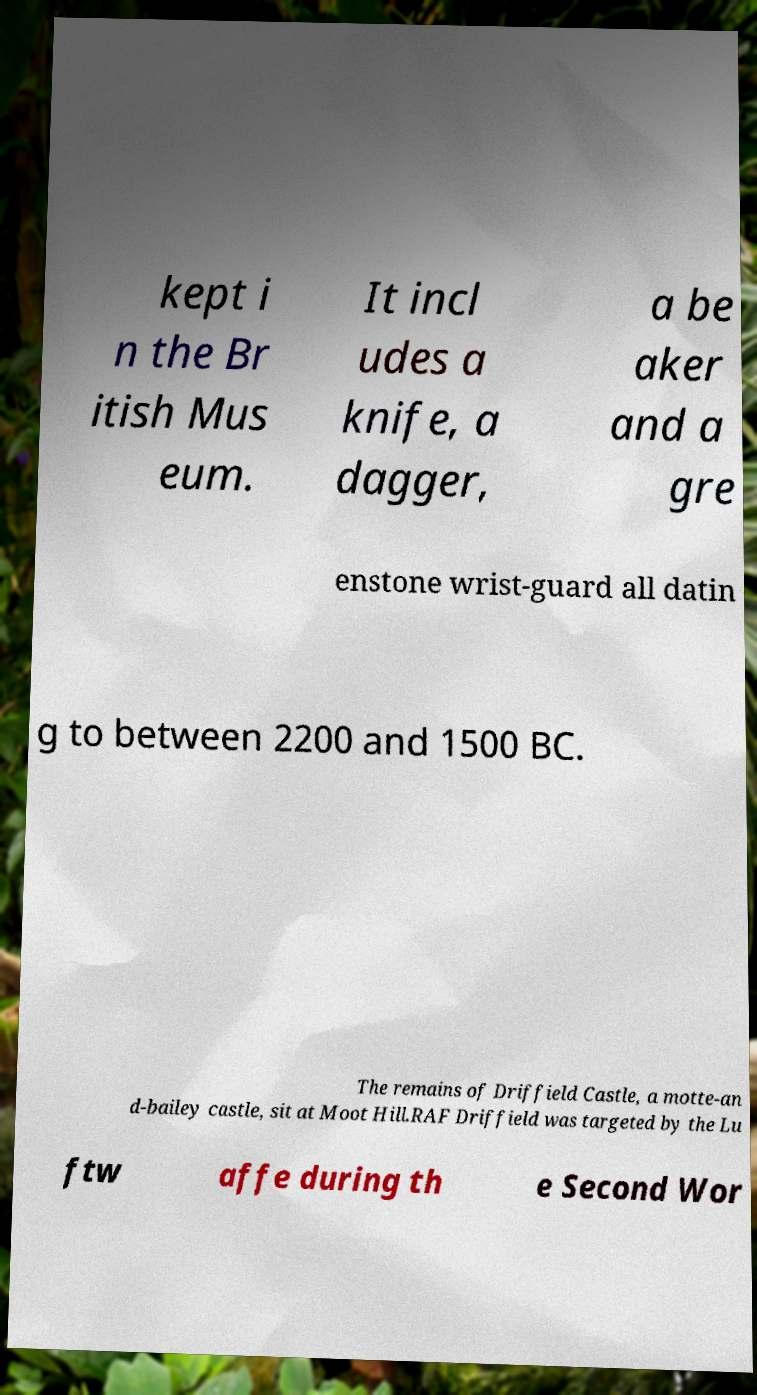Could you extract and type out the text from this image? kept i n the Br itish Mus eum. It incl udes a knife, a dagger, a be aker and a gre enstone wrist-guard all datin g to between 2200 and 1500 BC. The remains of Driffield Castle, a motte-an d-bailey castle, sit at Moot Hill.RAF Driffield was targeted by the Lu ftw affe during th e Second Wor 